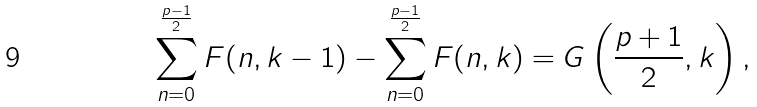Convert formula to latex. <formula><loc_0><loc_0><loc_500><loc_500>\sum _ { n = 0 } ^ { \frac { p - 1 } { 2 } } F ( n , k - 1 ) - \sum _ { n = 0 } ^ { \frac { p - 1 } { 2 } } F ( n , k ) = G \left ( \frac { p + 1 } { 2 } , k \right ) ,</formula> 